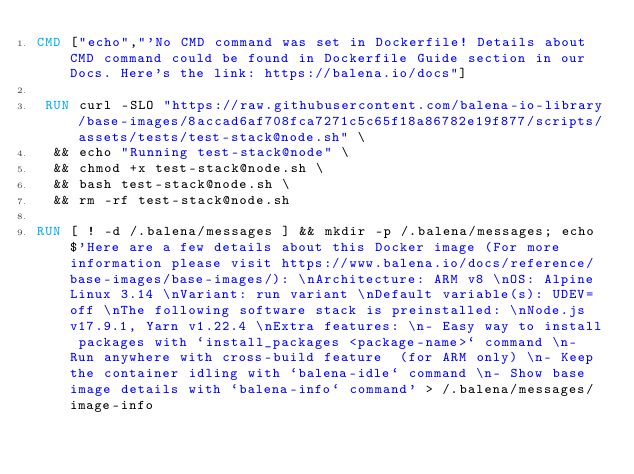Convert code to text. <code><loc_0><loc_0><loc_500><loc_500><_Dockerfile_>CMD ["echo","'No CMD command was set in Dockerfile! Details about CMD command could be found in Dockerfile Guide section in our Docs. Here's the link: https://balena.io/docs"]

 RUN curl -SLO "https://raw.githubusercontent.com/balena-io-library/base-images/8accad6af708fca7271c5c65f18a86782e19f877/scripts/assets/tests/test-stack@node.sh" \
  && echo "Running test-stack@node" \
  && chmod +x test-stack@node.sh \
  && bash test-stack@node.sh \
  && rm -rf test-stack@node.sh 

RUN [ ! -d /.balena/messages ] && mkdir -p /.balena/messages; echo $'Here are a few details about this Docker image (For more information please visit https://www.balena.io/docs/reference/base-images/base-images/): \nArchitecture: ARM v8 \nOS: Alpine Linux 3.14 \nVariant: run variant \nDefault variable(s): UDEV=off \nThe following software stack is preinstalled: \nNode.js v17.9.1, Yarn v1.22.4 \nExtra features: \n- Easy way to install packages with `install_packages <package-name>` command \n- Run anywhere with cross-build feature  (for ARM only) \n- Keep the container idling with `balena-idle` command \n- Show base image details with `balena-info` command' > /.balena/messages/image-info</code> 